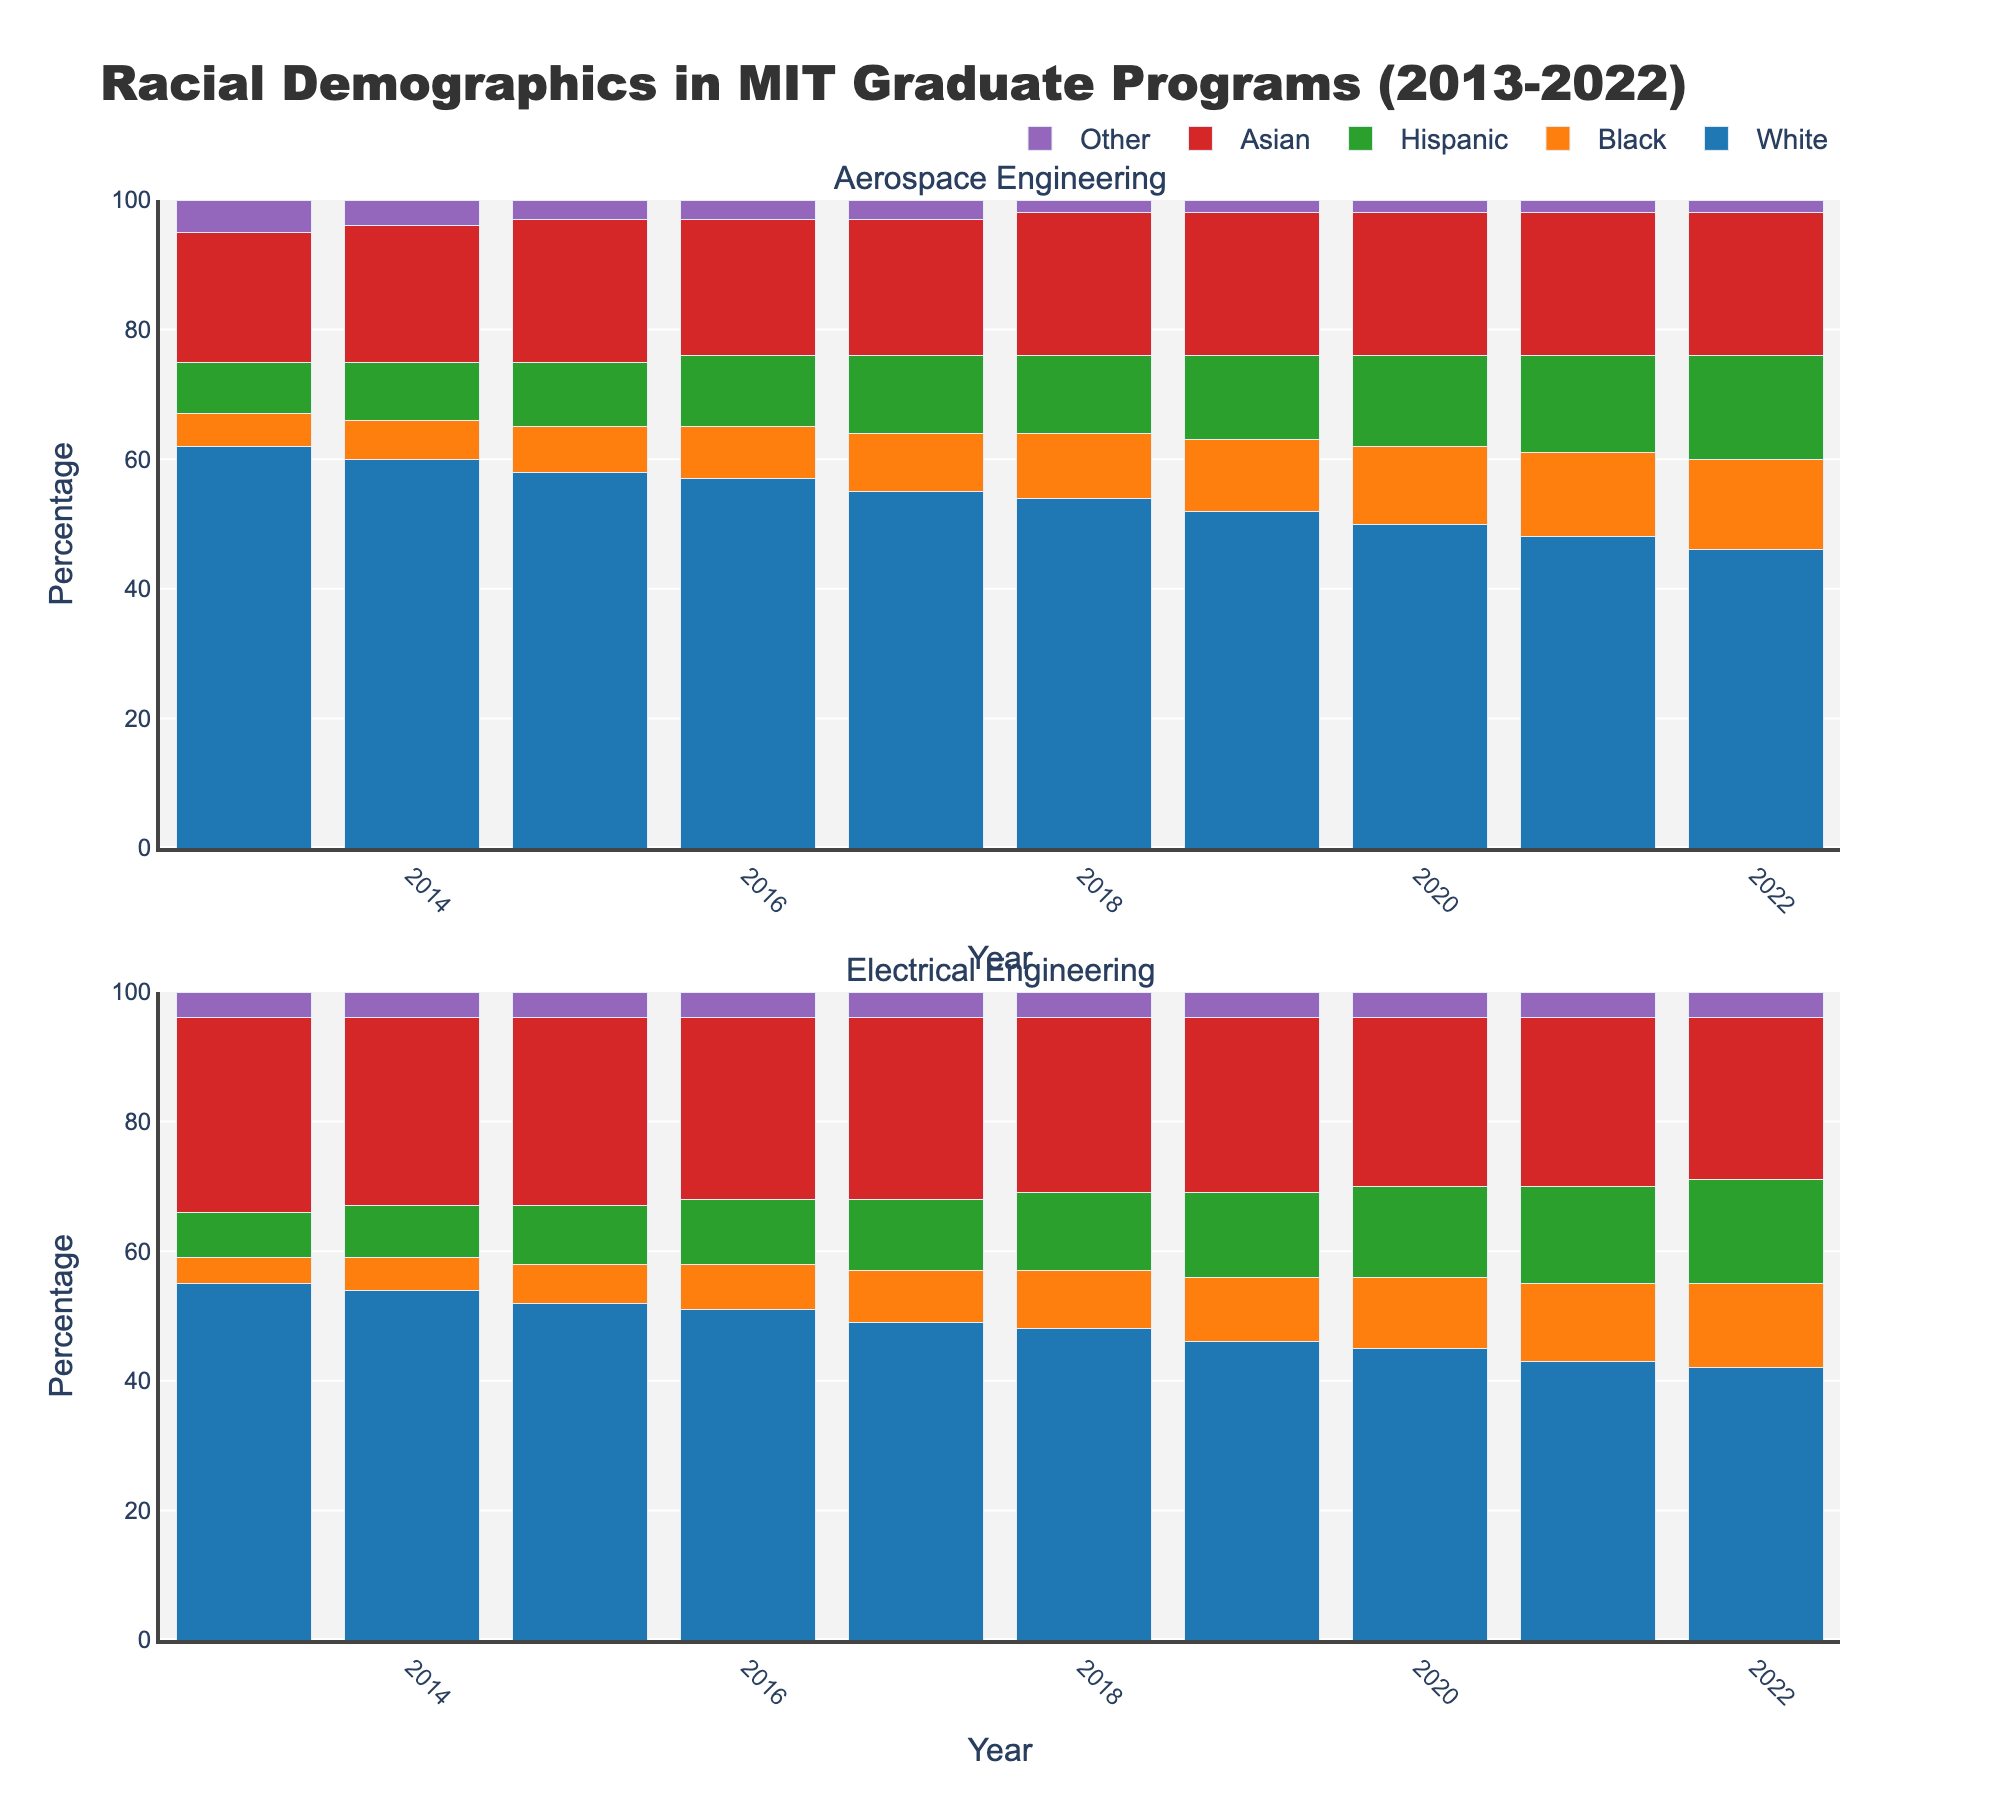What is the title of the figure? The title of the figure is located at the top of the plot. It provides information summarizing the contents of the figure.
Answer: Racial Demographics in MIT Graduate Programs (2013-2022) How does the percentage of Black students in Aerospace Engineering change from 2013 to 2022? By looking at the stacked bars in the Aerospace Engineering subplot across the years, we observe the segment representing Black students. From 2013 to 2022, the blue segment increases gradually each year.
Answer: It increases from 5% to 14% Which racial group consistently has the highest representation in both graduate programs? By comparing the different colored segments across all the bars in both subplots, it's clear that one color always occupies the largest section of the bars.
Answer: White What is the percentage difference between Hispanic and Asian students in Electrical Engineering in 2022? Find the segments for Hispanic and Asian students in the Electrical Engineering bar for 2022. Subtract the percentage for Asian students from the percentage for Hispanic students.
Answer: 16% - 25% = -9% In which year did the representation of Hispanic students in Aerospace Engineering match that of Electrical Engineering? Compare the heights of the respective segments of the bars. In 2017, both programs show similar heights for the Hispanic segments.
Answer: 2017 How did the composition of Asian students change in both programs over the decade? Observe the height of the red segment for Asian students across all bars in both subplots. Note any increases or decreases over the years. In Aerospace Engineering, the percentage remains stable between 20-22%. In Electrical Engineering, the percentage slightly decreases from 30% to 25%.
Answer: Stable in Aerospace Engineering, slight decrease in Electrical Engineering Which racial group shows the smallest relative change over the years in the Aerospace Engineering program? Calculate the percentage increase or decrease for each racial group from 2013 to 2022 based on the starting and ending points. The group with the smallest range is 'Asian.'
Answer: Asian What trend do you observe for the 'Other' racial group in both programs over the decade? Observe the purple segment representation in both subplots. It remains mostly constant each year in both subplots.
Answer: Mostly constant 